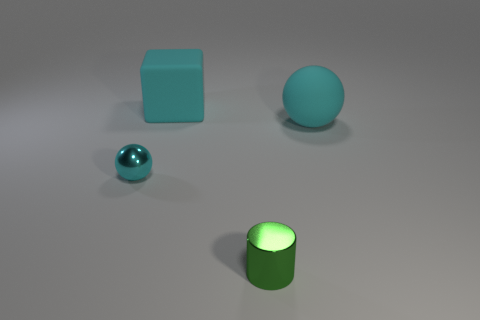Add 2 metallic balls. How many objects exist? 6 Subtract all cylinders. How many objects are left? 3 Add 4 large purple rubber cubes. How many large purple rubber cubes exist? 4 Subtract 0 gray cubes. How many objects are left? 4 Subtract all red cylinders. Subtract all yellow balls. How many cylinders are left? 1 Subtract all gray cubes. How many brown cylinders are left? 0 Subtract all large cyan matte spheres. Subtract all large green shiny spheres. How many objects are left? 3 Add 2 large balls. How many large balls are left? 3 